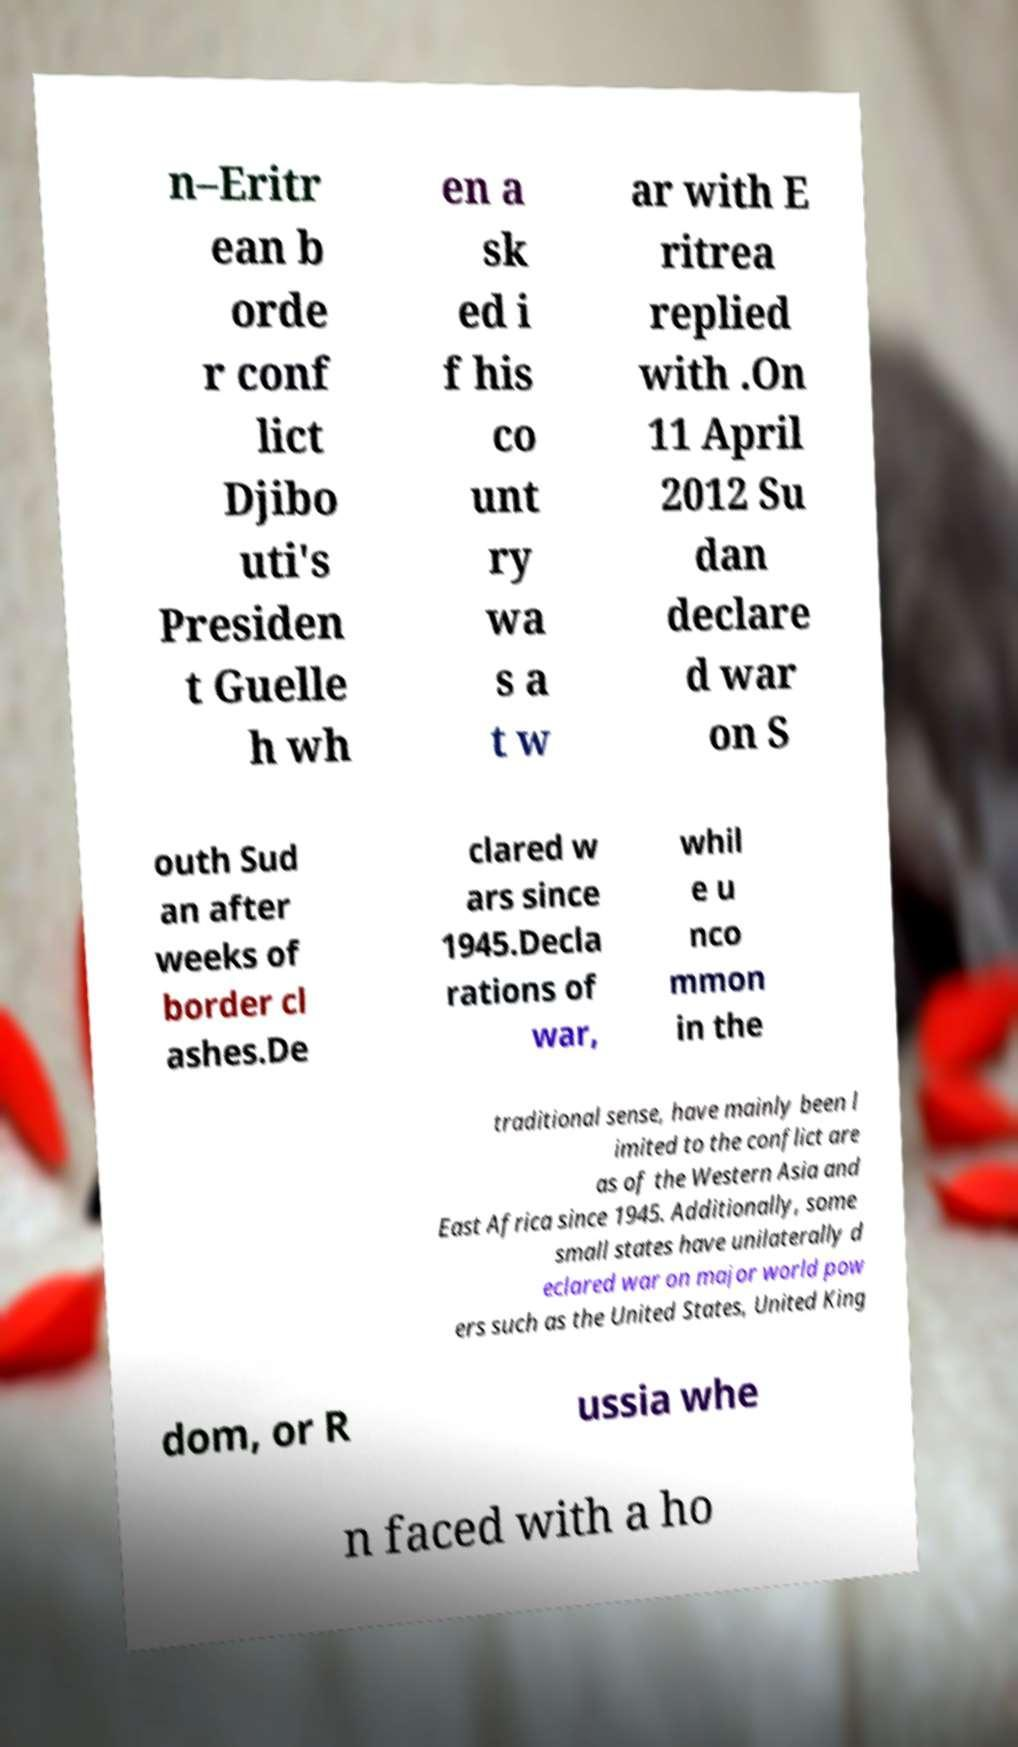Can you accurately transcribe the text from the provided image for me? n–Eritr ean b orde r conf lict Djibo uti's Presiden t Guelle h wh en a sk ed i f his co unt ry wa s a t w ar with E ritrea replied with .On 11 April 2012 Su dan declare d war on S outh Sud an after weeks of border cl ashes.De clared w ars since 1945.Decla rations of war, whil e u nco mmon in the traditional sense, have mainly been l imited to the conflict are as of the Western Asia and East Africa since 1945. Additionally, some small states have unilaterally d eclared war on major world pow ers such as the United States, United King dom, or R ussia whe n faced with a ho 